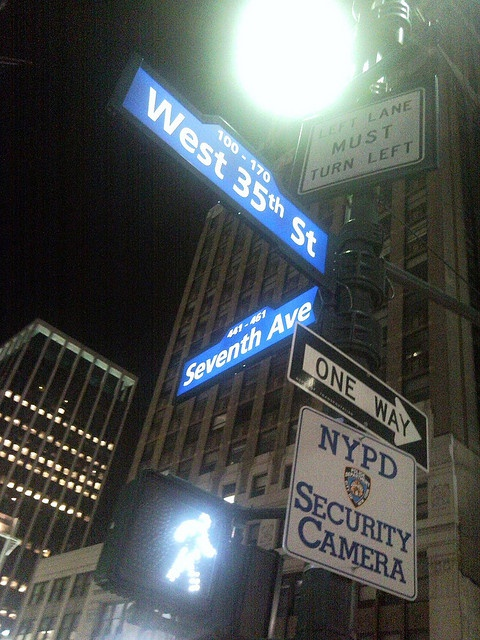Describe the objects in this image and their specific colors. I can see various objects in this image with different colors. 